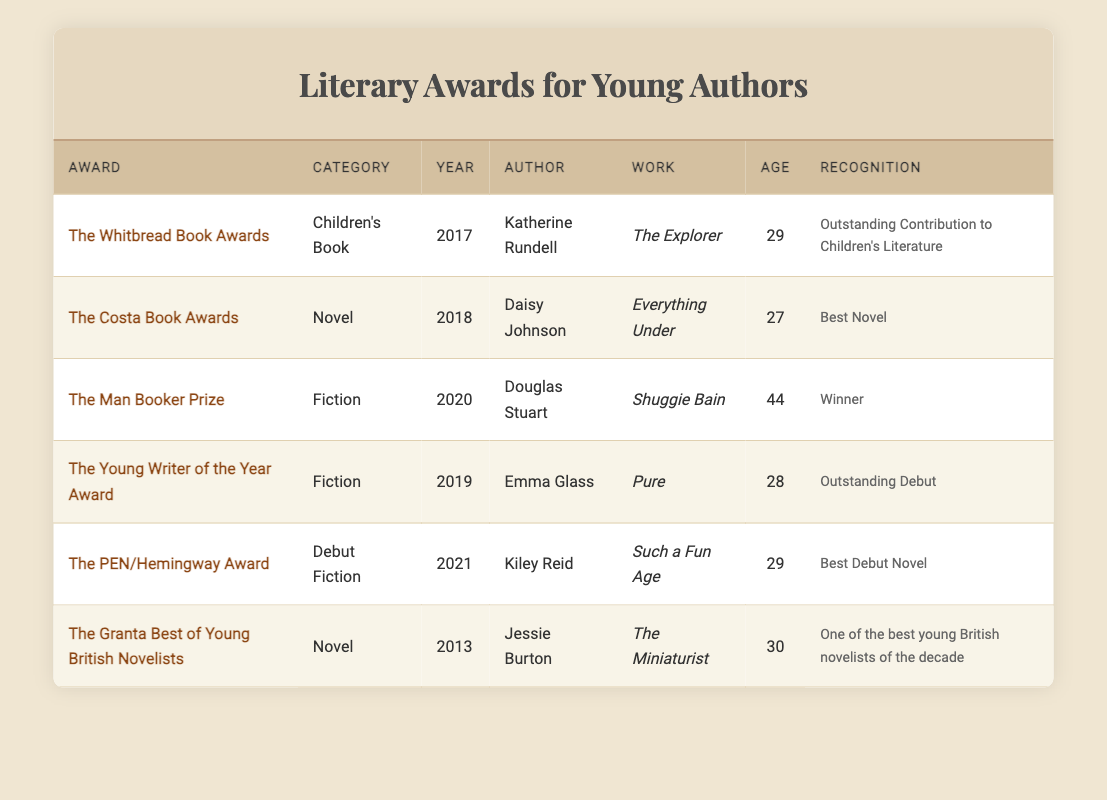What is the age of Kiley Reid when she won The PEN/Hemingway Award? The table states that Kiley Reid was 29 years old at the time she won The PEN/Hemingway Award in 2021.
Answer: 29 Who authored the work "Everything Under"? According to the table, the author of "Everything Under" is Daisy Johnson, recognized with The Costa Book Awards in 2018.
Answer: Daisy Johnson Which award was given for the best debut novel? The PEN/Hemingway Award was awarded to Kiley Reid for her work "Such a Fun Age", recognized as the best debut novel in 2021.
Answer: The PEN/Hemingway Award Are all authors in the table under the age of 30? Analyzing the ages, Douglas Stuart is 44 years old, while the other authors listed are under 30 years old. Thus, not all authors are under the age of 30.
Answer: No What has been the highest age at which an author in this inventory received an award? The highest age mentioned is 44, which pertains to Douglas Stuart when he received The Man Booker Prize in 2020.
Answer: 44 How many awards were recognized for children's literature? From the table, only The Whitbread Book Awards given to Katherine Rundell for "The Explorer" in 2017 is categorized under children's literature. Therefore, there is just one award for this category.
Answer: 1 Which author received an award for outstanding debut? Emma Glass received The Young Writer of the Year Award in 2019 for her work "Pure," recognized for outstanding debut.
Answer: Emma Glass What is the common age of authors who won awards in 2018 and 2021? In 2018, Daisy Johnson was 27 and in 2021 Kiley Reid was 29. To find the common age, calculate the average: (27+29)/2 = 28.
Answer: 28 Which award was highlighted for recognizing a significant contribution to children's literature? The award focused on highlighting outstanding contributions to children's literature is The Whitbread Book Awards given to Katherine Rundell for "The Explorer" in 2017.
Answer: The Whitbread Book Awards 